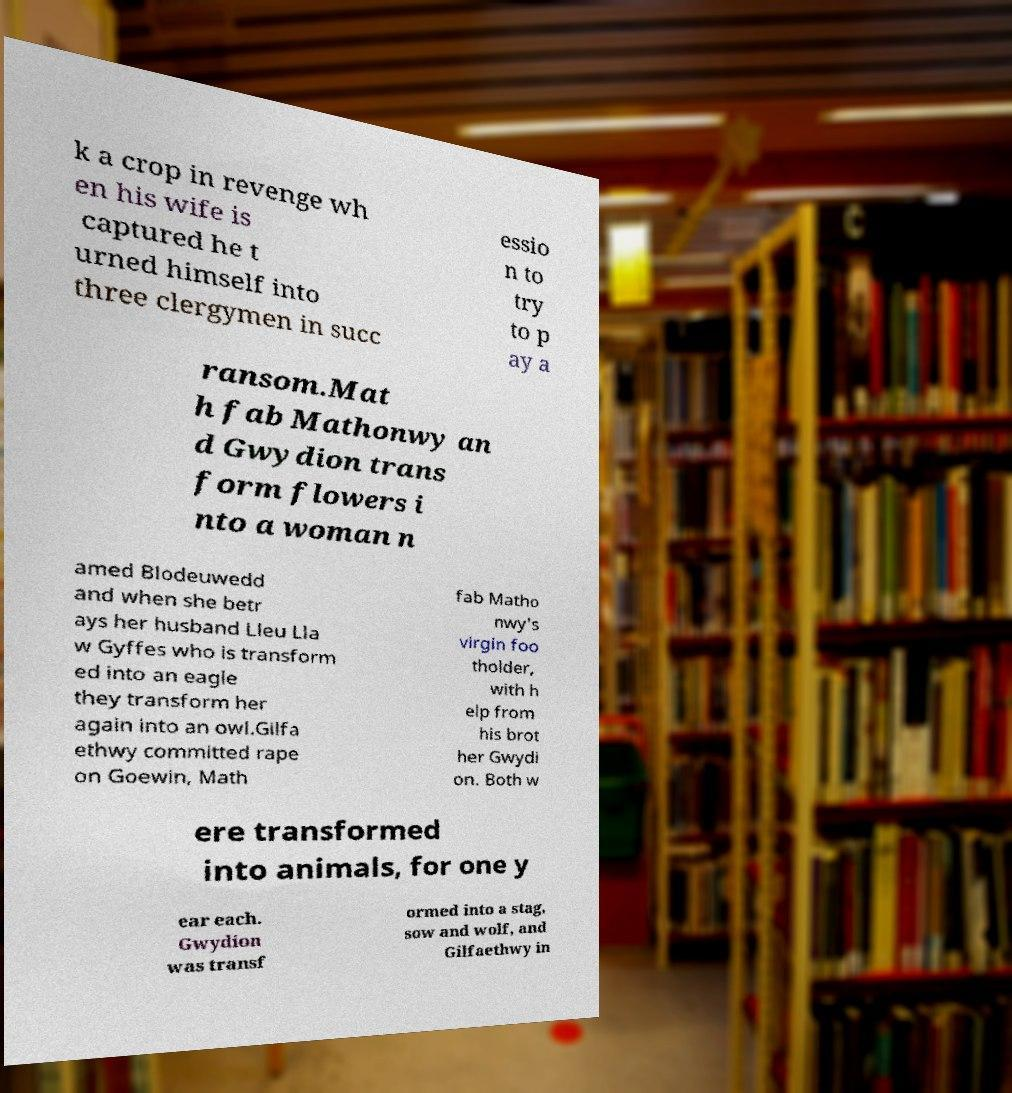Please identify and transcribe the text found in this image. k a crop in revenge wh en his wife is captured he t urned himself into three clergymen in succ essio n to try to p ay a ransom.Mat h fab Mathonwy an d Gwydion trans form flowers i nto a woman n amed Blodeuwedd and when she betr ays her husband Lleu Lla w Gyffes who is transform ed into an eagle they transform her again into an owl.Gilfa ethwy committed rape on Goewin, Math fab Matho nwy's virgin foo tholder, with h elp from his brot her Gwydi on. Both w ere transformed into animals, for one y ear each. Gwydion was transf ormed into a stag, sow and wolf, and Gilfaethwy in 